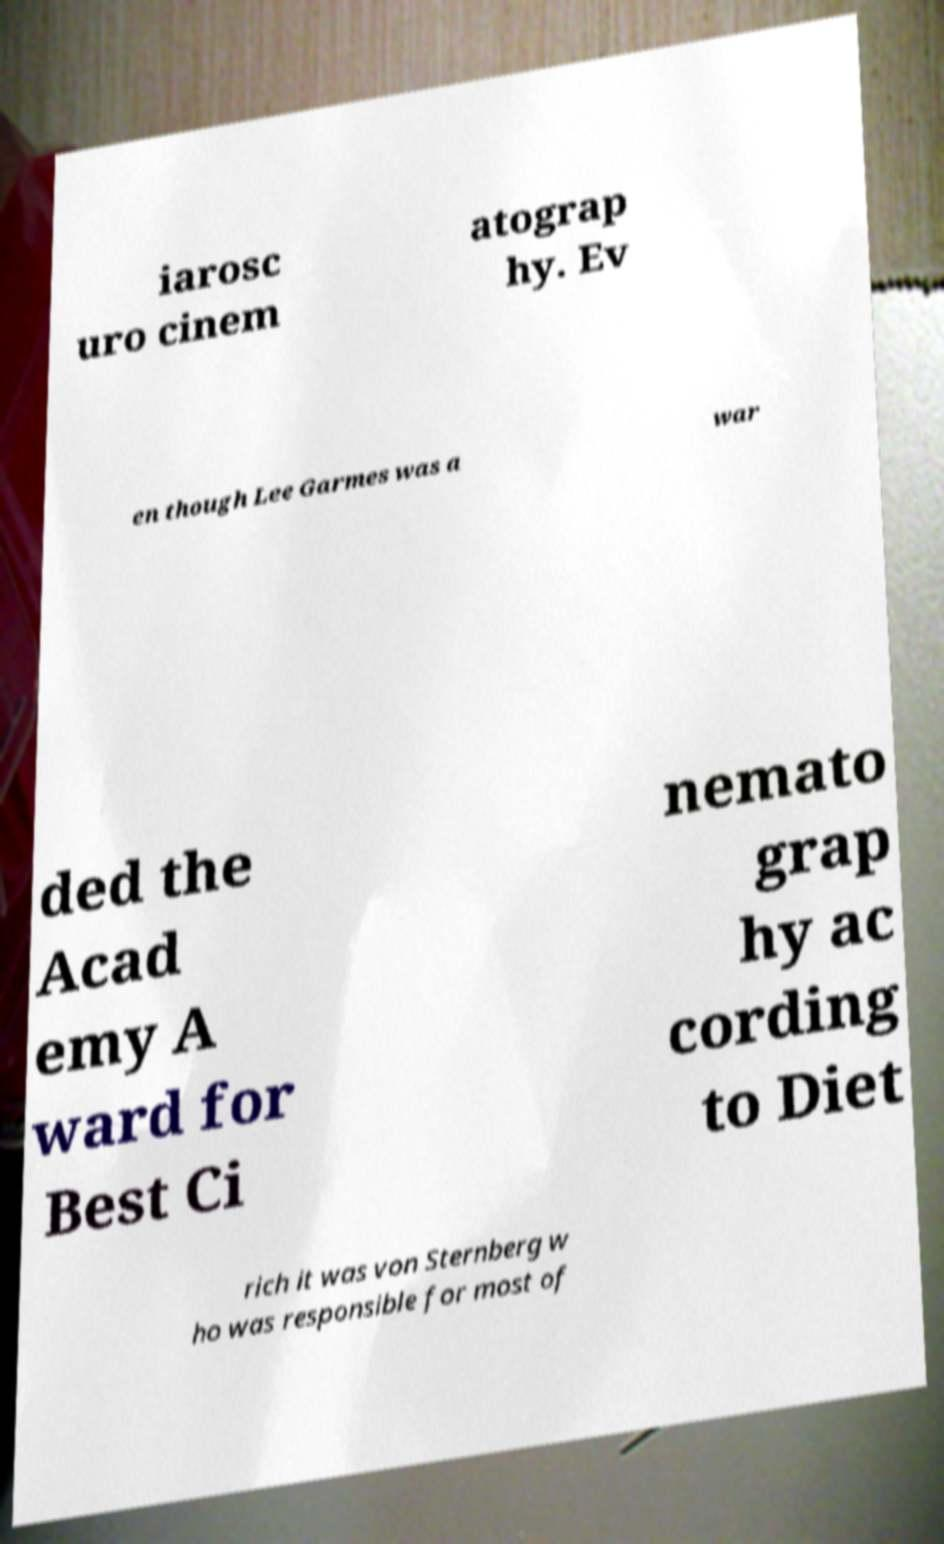There's text embedded in this image that I need extracted. Can you transcribe it verbatim? iarosc uro cinem atograp hy. Ev en though Lee Garmes was a war ded the Acad emy A ward for Best Ci nemato grap hy ac cording to Diet rich it was von Sternberg w ho was responsible for most of 